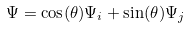<formula> <loc_0><loc_0><loc_500><loc_500>\Psi = \cos ( \theta ) { \Psi } _ { i } + \sin ( \theta ) { \Psi } _ { j }</formula> 